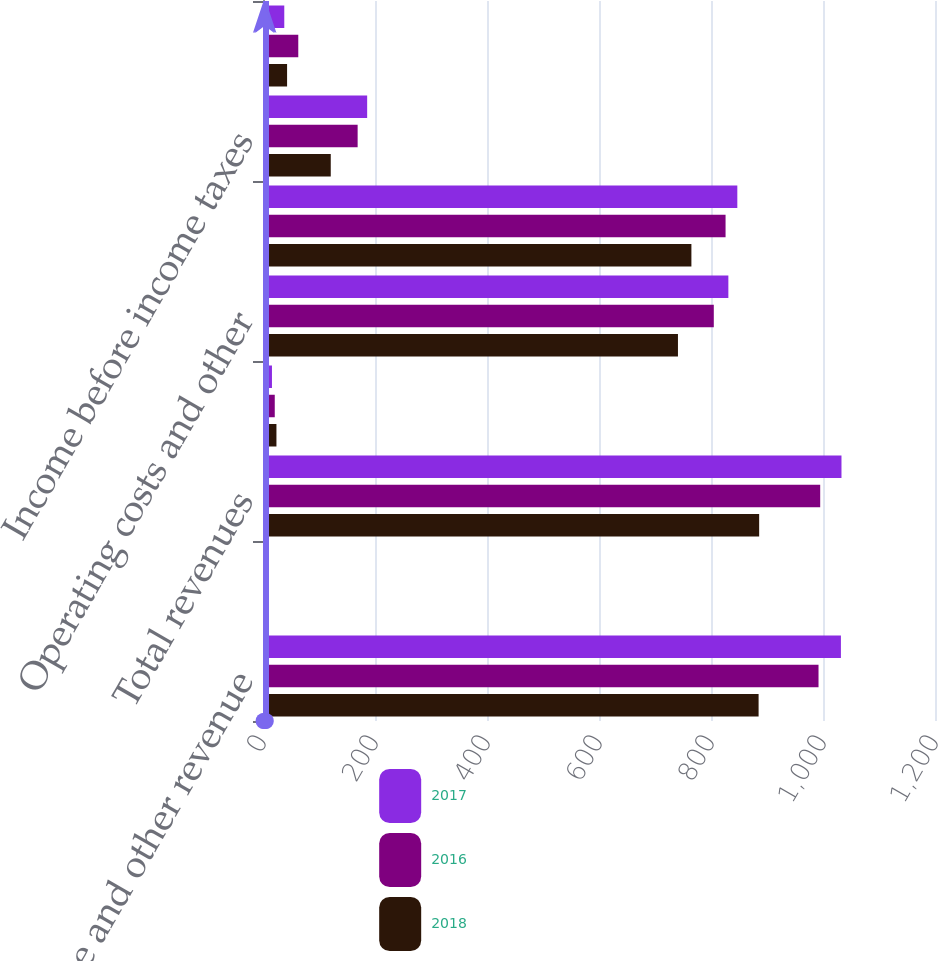Convert chart to OTSL. <chart><loc_0><loc_0><loc_500><loc_500><stacked_bar_chart><ecel><fcel>Fee income and other revenue<fcel>Net investment income<fcel>Total revenues<fcel>Amortization of DAC<fcel>Operating costs and other<fcel>Total benefits losses and<fcel>Income before income taxes<fcel>Income tax expense 2<nl><fcel>2017<fcel>1032<fcel>5<fcel>1033<fcel>16<fcel>831<fcel>847<fcel>186<fcel>38<nl><fcel>2016<fcel>992<fcel>3<fcel>995<fcel>21<fcel>805<fcel>826<fcel>169<fcel>63<nl><fcel>2018<fcel>885<fcel>1<fcel>886<fcel>24<fcel>741<fcel>765<fcel>121<fcel>43<nl></chart> 